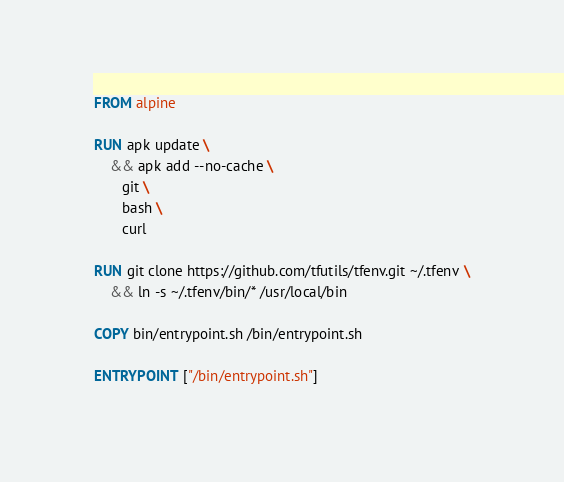Convert code to text. <code><loc_0><loc_0><loc_500><loc_500><_Dockerfile_>FROM alpine

RUN apk update \
    && apk add --no-cache \
       git \
       bash \
       curl

RUN git clone https://github.com/tfutils/tfenv.git ~/.tfenv \
    && ln -s ~/.tfenv/bin/* /usr/local/bin

COPY bin/entrypoint.sh /bin/entrypoint.sh

ENTRYPOINT ["/bin/entrypoint.sh"]
</code> 